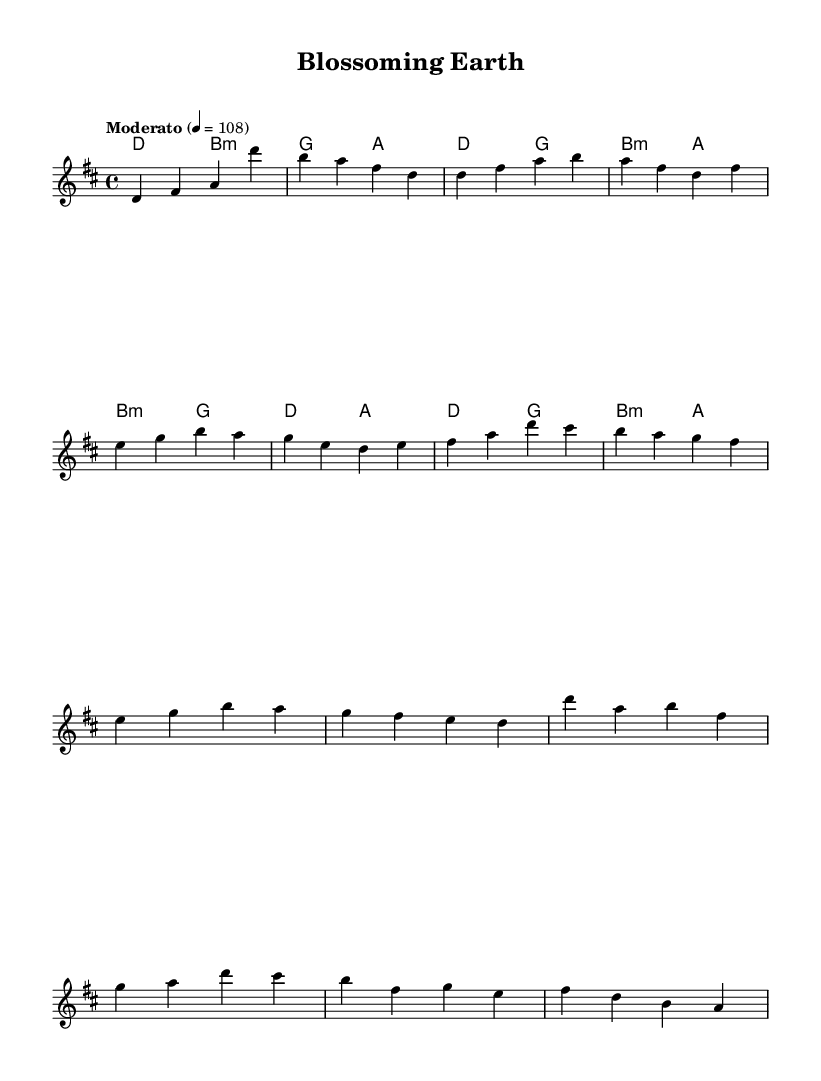What is the key signature of this music? The key signature of this music is D major, which has two sharps (F# and C#). This can be identified by looking at the key signature at the beginning of the sheet music.
Answer: D major What is the time signature of this music? The time signature of this music is 4/4. This is indicated at the beginning of the score, showing that there are four beats per measure.
Answer: 4/4 What is the tempo marking of this piece? The tempo marking indicates a speed of "Moderato" at 108 beats per minute. This is specified at the top of the sheet music under the tempo section.
Answer: Moderato How many measures are in the melody before the chorus begins? The melody has 8 measures from the start (Intro + Verse + Pre-chorus) before reaching the chorus. By counting the measures in the indicated sections, we find this total.
Answer: 8 What is the last chord in the score? The last chord in the score is A major. This can be determined by looking at the final entry in the harmonies section of the score, where A major is indicated.
Answer: A major What is the main theme conveyed in the lyrics implied by the melody and harmony progression? The melody and harmony progression together feature uplifting and bright tones, which are characteristic of a celebratory theme celebrating nature. This is inferred from the overall tonality and lyrical intent typically seen in K-Pop songs that emphasize positive elements about nature.
Answer: Celebrating nature 